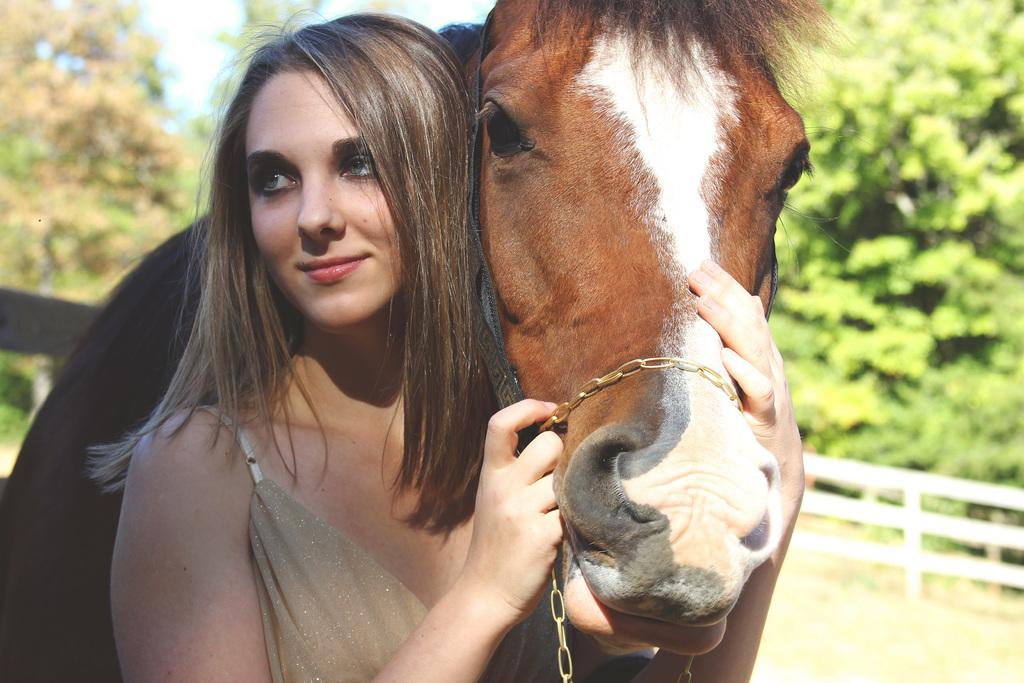Who is the main subject in the image? There is a woman in the image. What is the woman doing in the image? The woman is standing and holding a horse with her hands. What can be seen in the background of the image? There are trees visible in the background of the image. What type of brass or copper material is being used by the governor in the image? There is no brass, copper, or governor present in the image. 